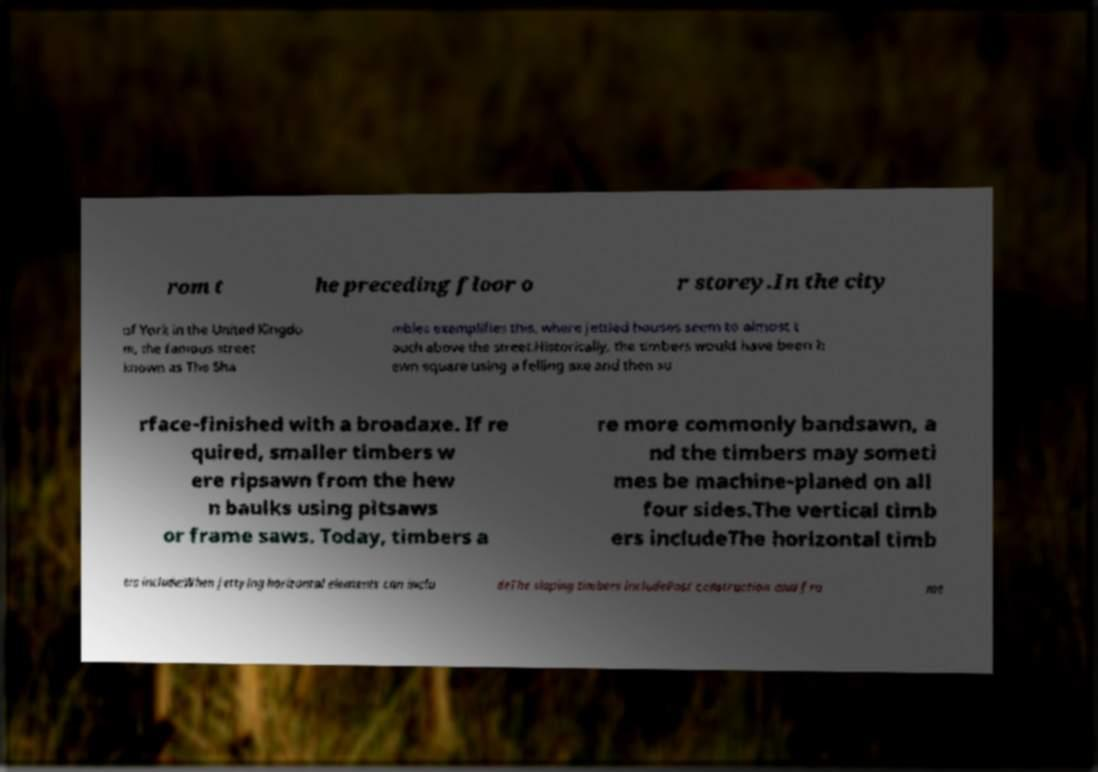Can you accurately transcribe the text from the provided image for me? rom t he preceding floor o r storey.In the city of York in the United Kingdo m, the famous street known as The Sha mbles exemplifies this, where jettied houses seem to almost t ouch above the street.Historically, the timbers would have been h ewn square using a felling axe and then su rface-finished with a broadaxe. If re quired, smaller timbers w ere ripsawn from the hew n baulks using pitsaws or frame saws. Today, timbers a re more commonly bandsawn, a nd the timbers may someti mes be machine-planed on all four sides.The vertical timb ers includeThe horizontal timb ers include:When jettying horizontal elements can inclu deThe sloping timbers includePost construction and fra me 